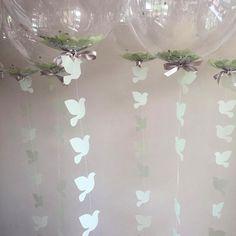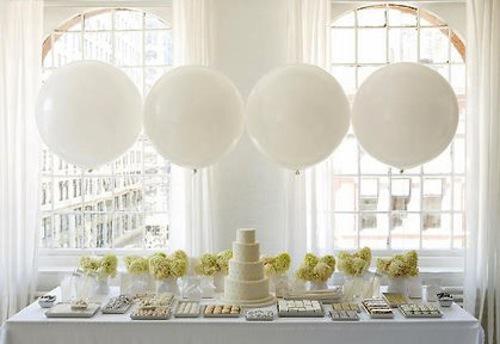The first image is the image on the left, the second image is the image on the right. For the images displayed, is the sentence "There are ornaments hanging down from balloons so clear they are nearly invisible." factually correct? Answer yes or no. Yes. The first image is the image on the left, the second image is the image on the right. Given the left and right images, does the statement "Some balloons are clear." hold true? Answer yes or no. Yes. 